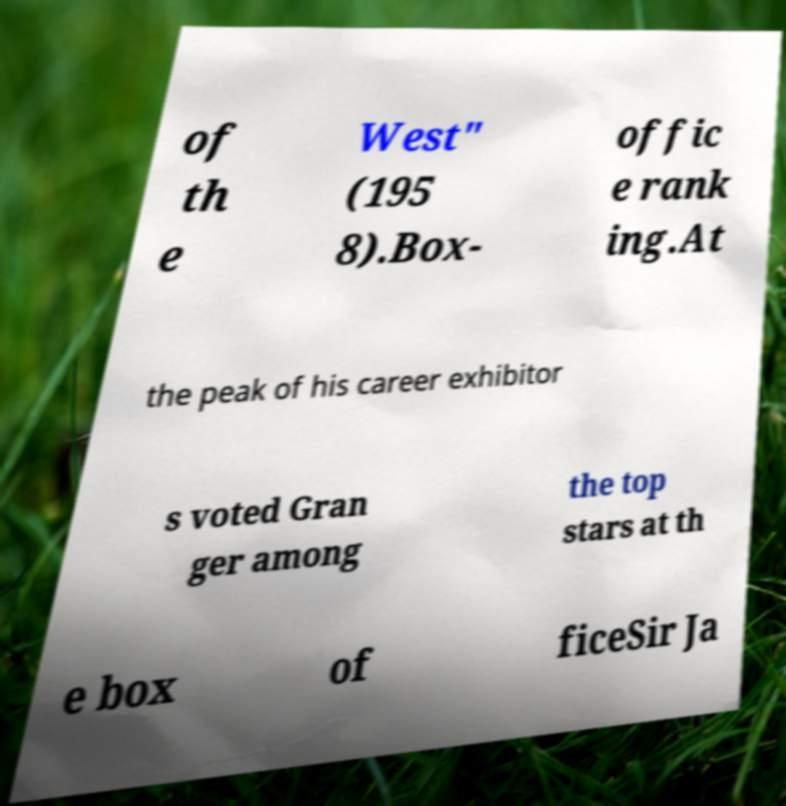Can you accurately transcribe the text from the provided image for me? of th e West" (195 8).Box- offic e rank ing.At the peak of his career exhibitor s voted Gran ger among the top stars at th e box of ficeSir Ja 